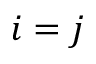Convert formula to latex. <formula><loc_0><loc_0><loc_500><loc_500>i = j</formula> 